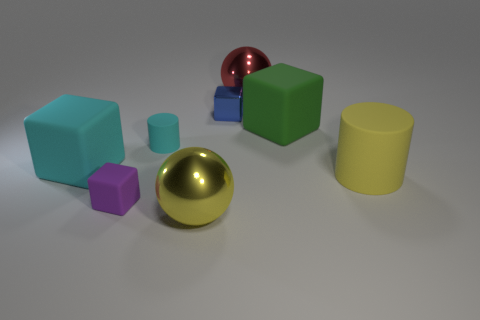Add 1 large red balls. How many objects exist? 9 Subtract all cyan cylinders. How many cylinders are left? 1 Subtract all purple blocks. How many blocks are left? 3 Subtract 2 cylinders. How many cylinders are left? 0 Subtract all cylinders. How many objects are left? 6 Subtract all green blocks. Subtract all brown balls. How many blocks are left? 3 Subtract all gray cylinders. How many red spheres are left? 1 Add 2 matte things. How many matte things are left? 7 Add 1 big yellow spheres. How many big yellow spheres exist? 2 Subtract 1 red spheres. How many objects are left? 7 